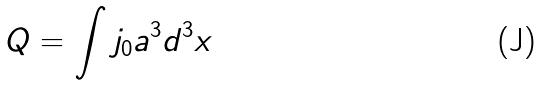Convert formula to latex. <formula><loc_0><loc_0><loc_500><loc_500>Q = \int j _ { 0 } a ^ { 3 } d ^ { 3 } x</formula> 